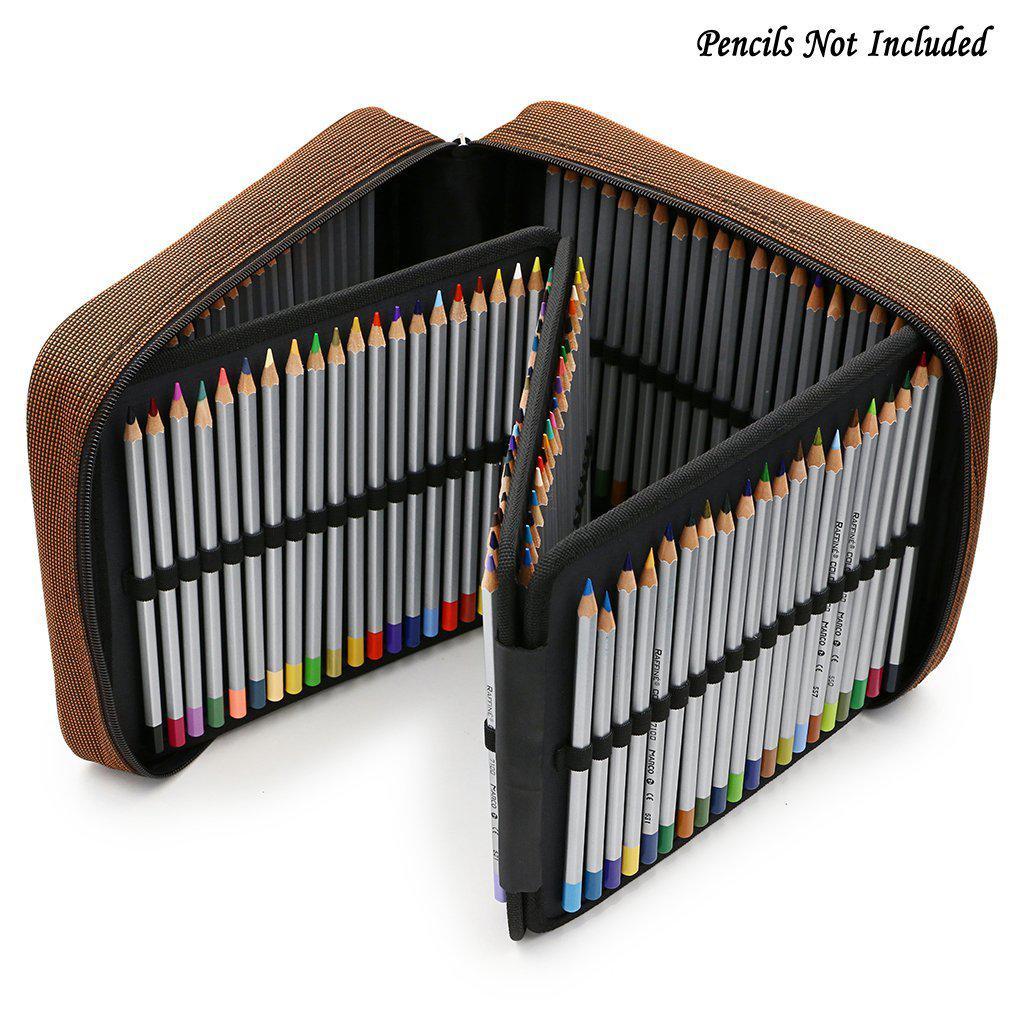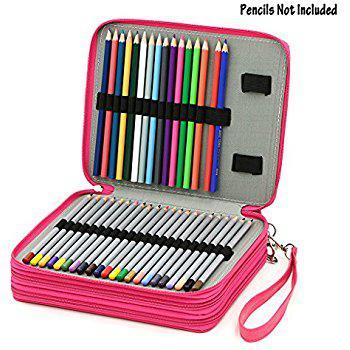The first image is the image on the left, the second image is the image on the right. Examine the images to the left and right. Is the description "All of the pencil cases are standing on their sides." accurate? Answer yes or no. No. 